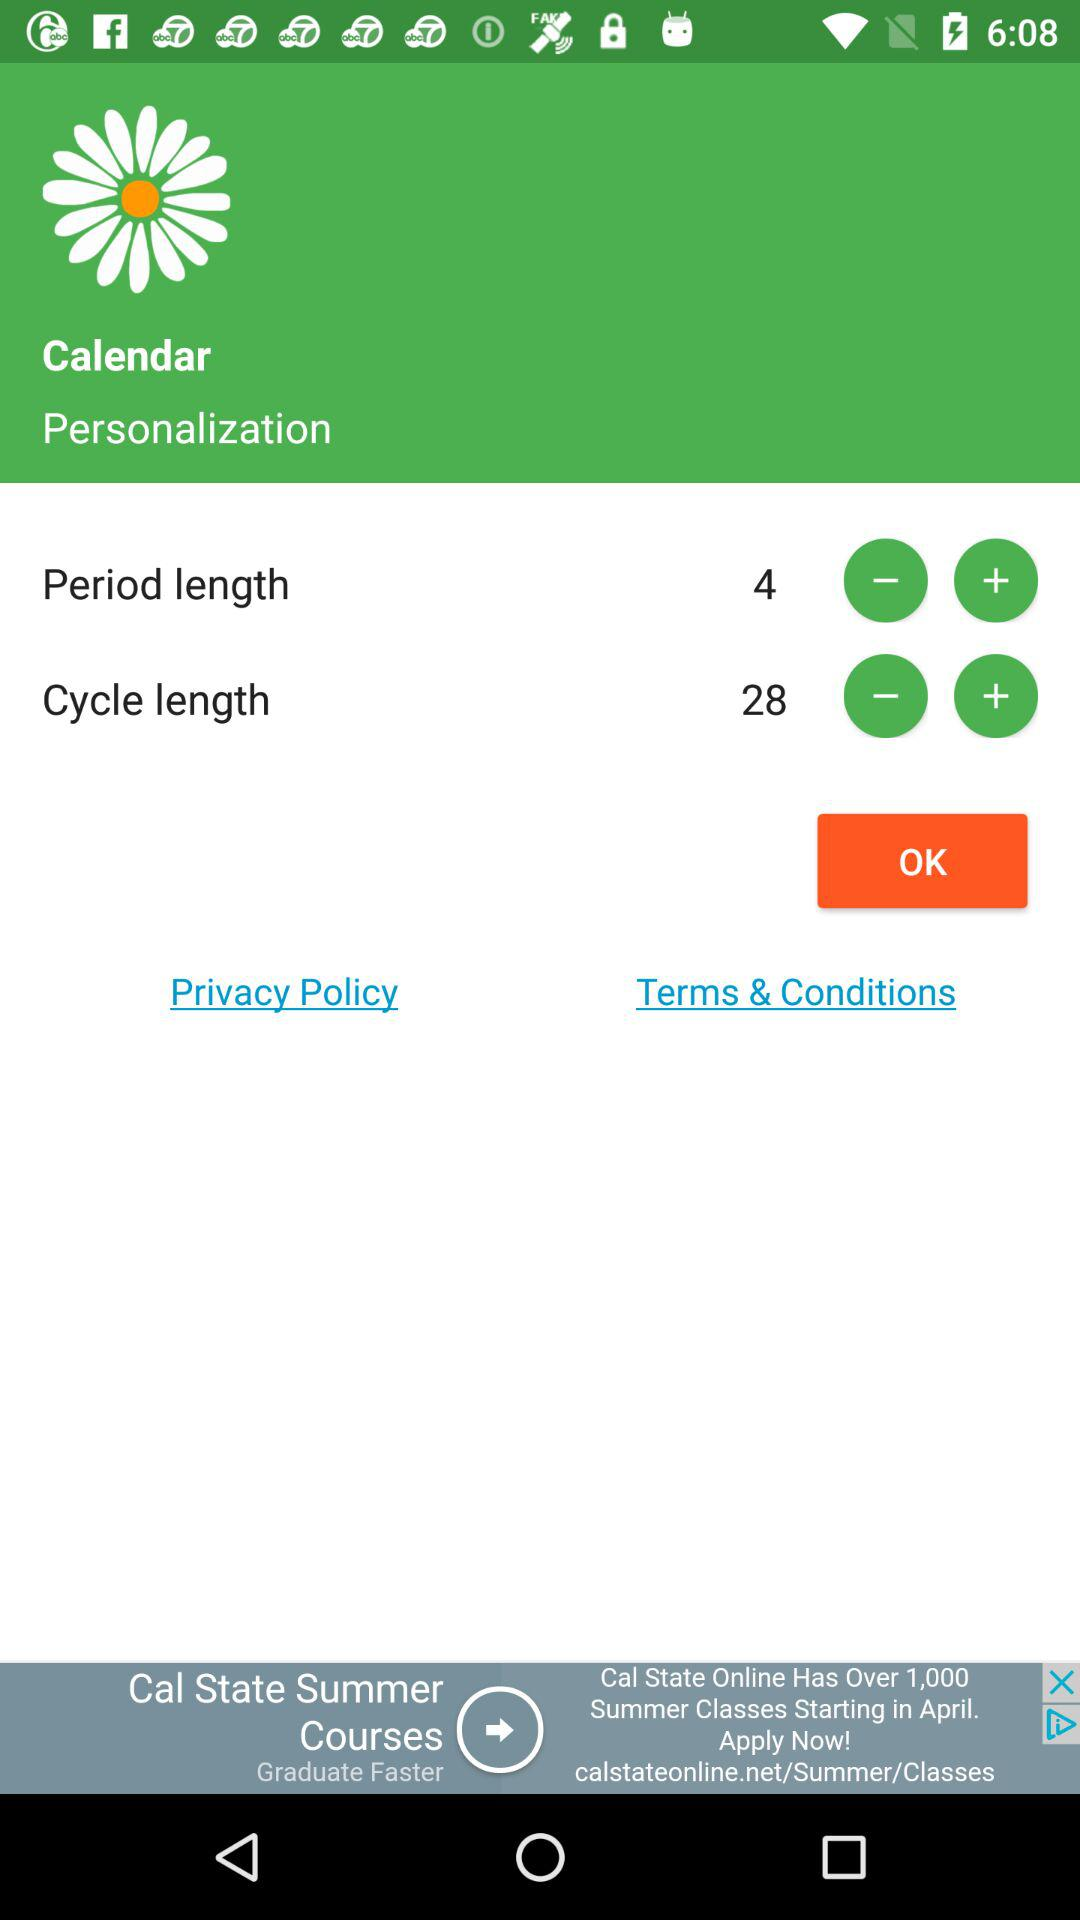What is the cycle length? The cycle length is 28. 